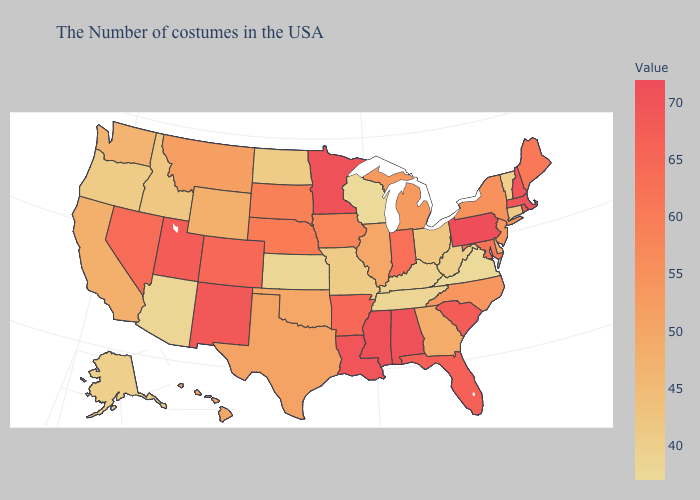Does Colorado have a higher value than Rhode Island?
Be succinct. No. Which states have the lowest value in the West?
Quick response, please. Arizona. Does Colorado have the lowest value in the West?
Answer briefly. No. Among the states that border Tennessee , which have the highest value?
Write a very short answer. Alabama, Mississippi. Does Minnesota have the highest value in the MidWest?
Quick response, please. Yes. Does New Jersey have a higher value than Nevada?
Short answer required. No. Does Montana have the lowest value in the USA?
Keep it brief. No. 